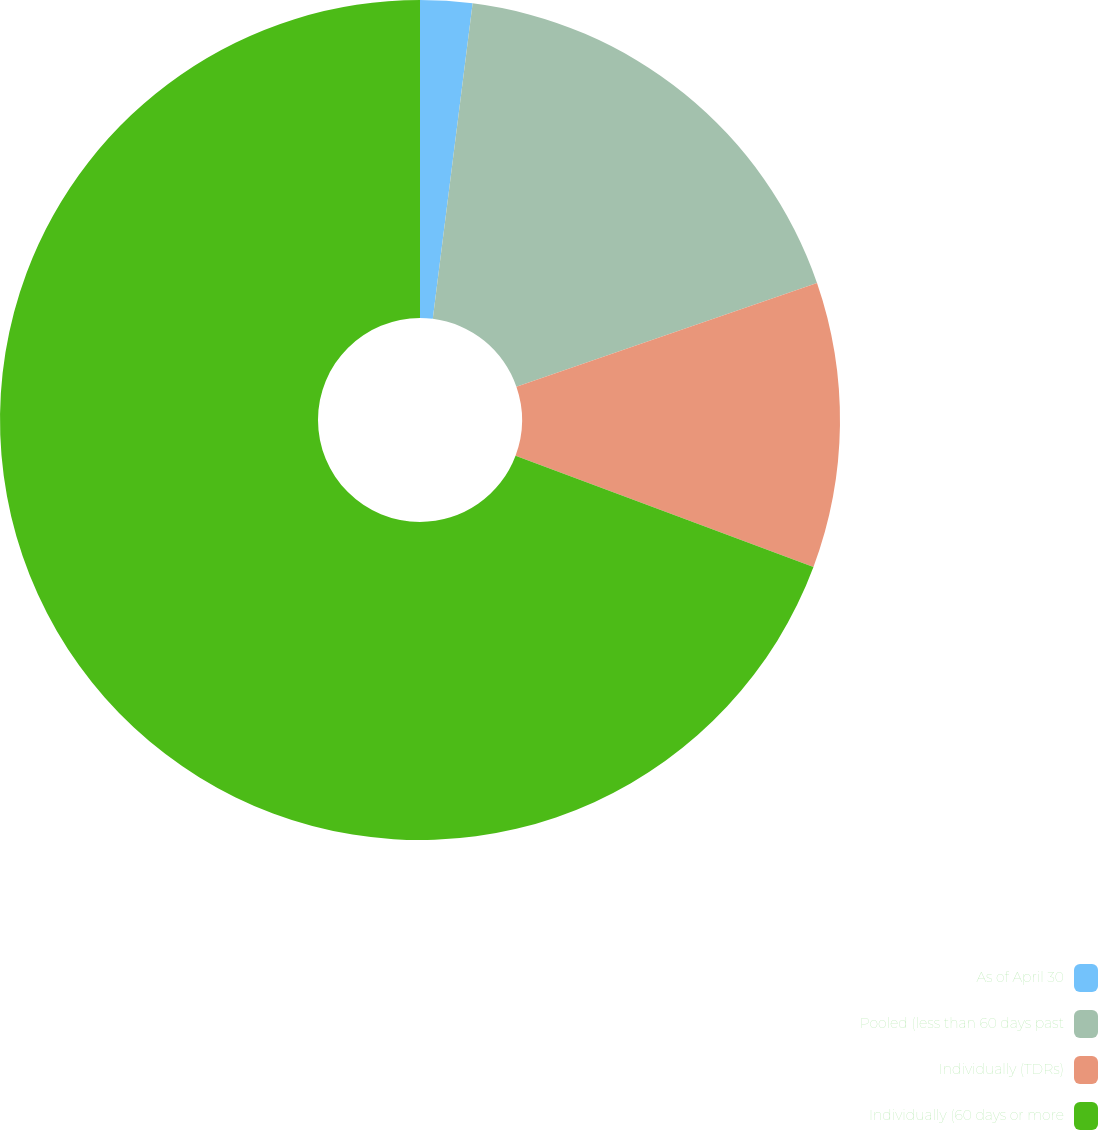Convert chart to OTSL. <chart><loc_0><loc_0><loc_500><loc_500><pie_chart><fcel>As of April 30<fcel>Pooled (less than 60 days past<fcel>Individually (TDRs)<fcel>Individually (60 days or more<nl><fcel>2.0%<fcel>17.71%<fcel>10.98%<fcel>69.31%<nl></chart> 